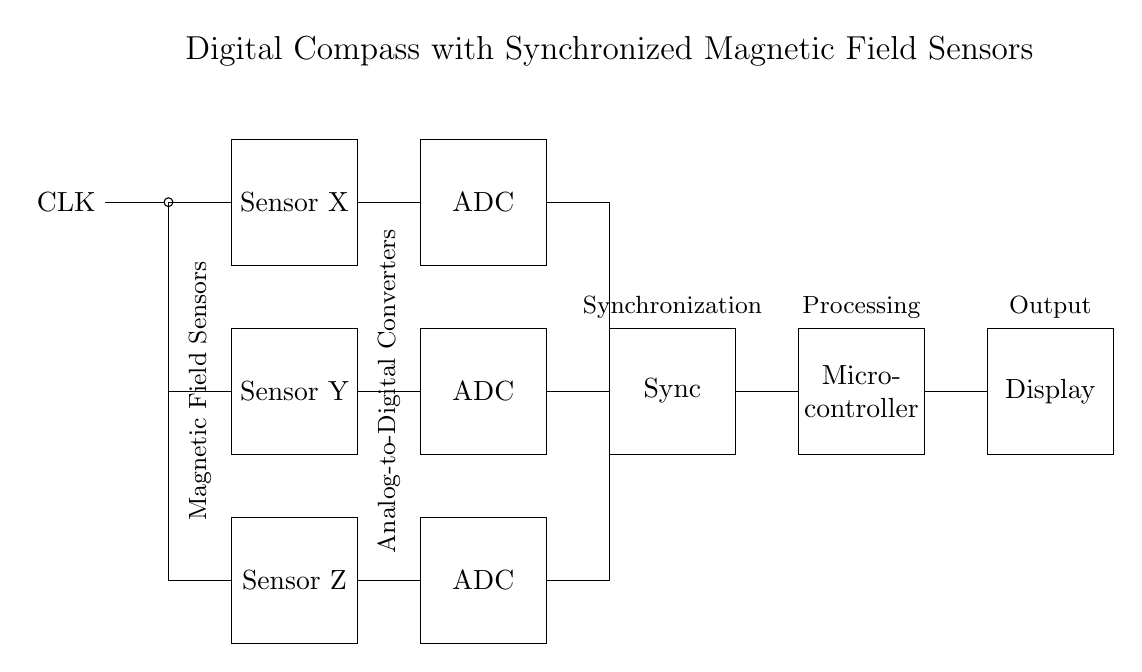What type of sensors are used in this circuit? The circuit diagram shows three magnetic field sensors labeled as Sensor X, Sensor Y, and Sensor Z. These sensors are used to detect magnetic fields for navigation purposes.
Answer: magnetic field sensors How many Analog-to-Digital Converters are there? There are three Analog-to-Digital Converters (ADCs) in the diagram, corresponding to each magnetic field sensor. Each ADC converts the analog signals from the sensors into digital format for further processing.
Answer: three What is the role of the synchronization block? The synchronization block ensures that the data from the multiple sensors is coordinated and aligned in time, allowing for accurate readings and improved navigation accuracy. This is crucial in a circuit with multiple sensors to maintain consistency.
Answer: data coordination What component precedes the microcontroller in the circuit? The synchronization block comes before the microcontroller in the circuit. It processes the synchronized data from the ADCs before sending it to the microcontroller for further analysis and decision-making.
Answer: synchronization block What is the output of this circuit? The output of this circuit is a display that presents the processed navigation data from the microcontroller. This could show the current heading or orientation based on the readings from the magnetic field sensors.
Answer: display What connects the magnetic field sensors to the ADCs? The connection from the magnetic field sensors to the ADCs is made by lines that indicate signal transmission. Each sensor's output connects to its corresponding ADC for conversion.
Answer: signal lines How many components are shown in the display section of the circuit? The display section of the circuit consists of a single component labeled "Display," which serves as the output interface for the navigation information processed by the microcontroller.
Answer: one component 